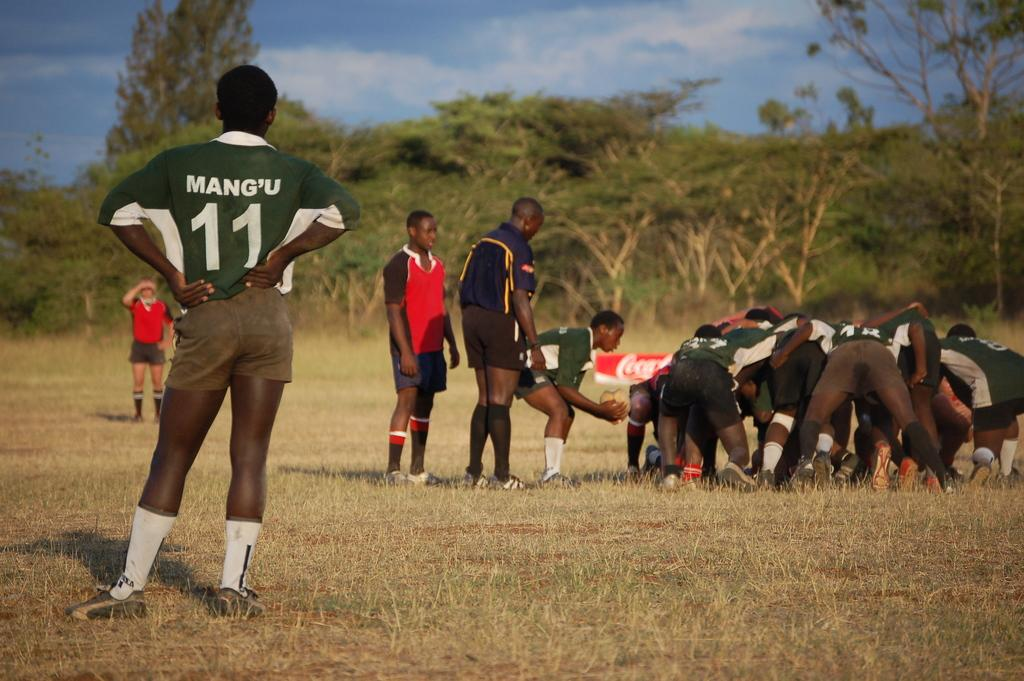<image>
Offer a succinct explanation of the picture presented. Number 11 stands to the side watching the other players. 